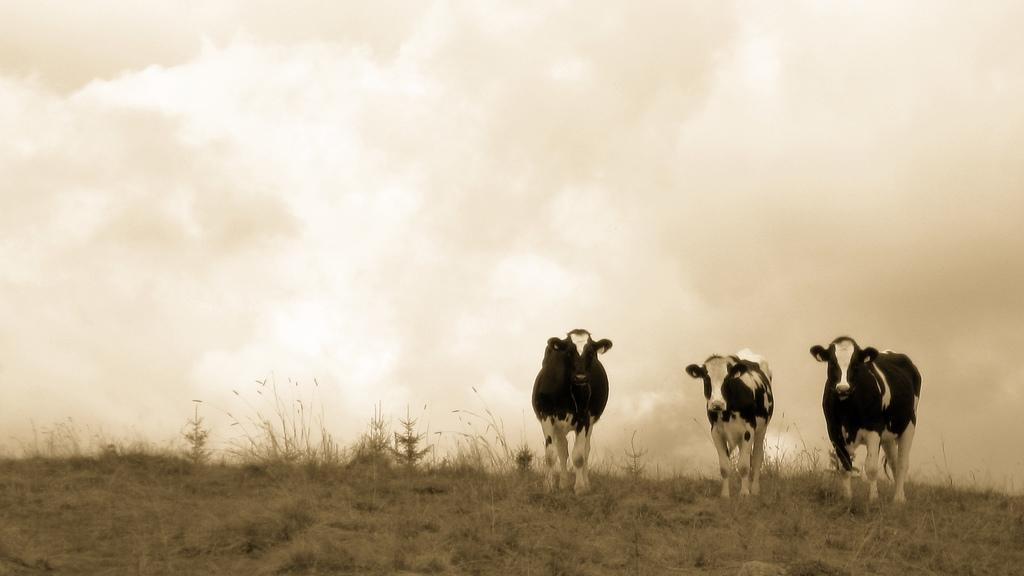How many crows are present in the image? There are 3 crows in the image. What are the crows doing in the image? The crows are standing on the grass. What can be seen in the sky in the image? There are clouds in the sky. What type of insurance policy do the crows have in the image? There is no mention of insurance or any insurance policies in the image, as it features crows standing on the grass with clouds in the sky. 